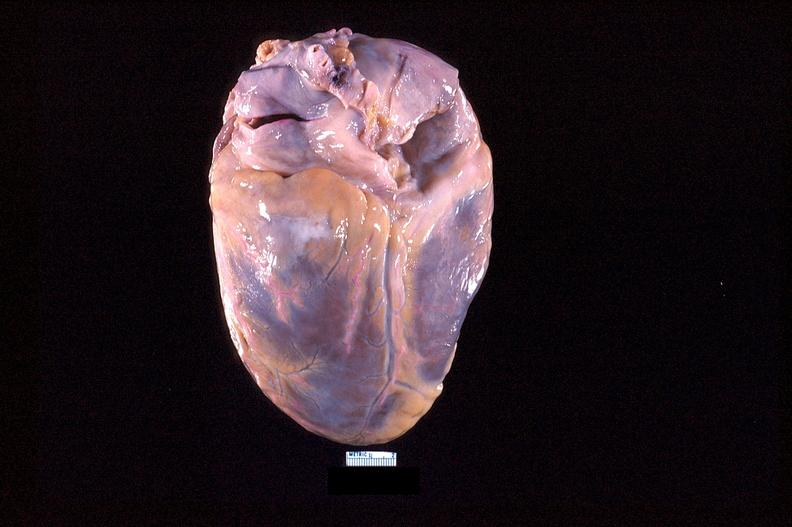what is present?
Answer the question using a single word or phrase. Cardiovascular 